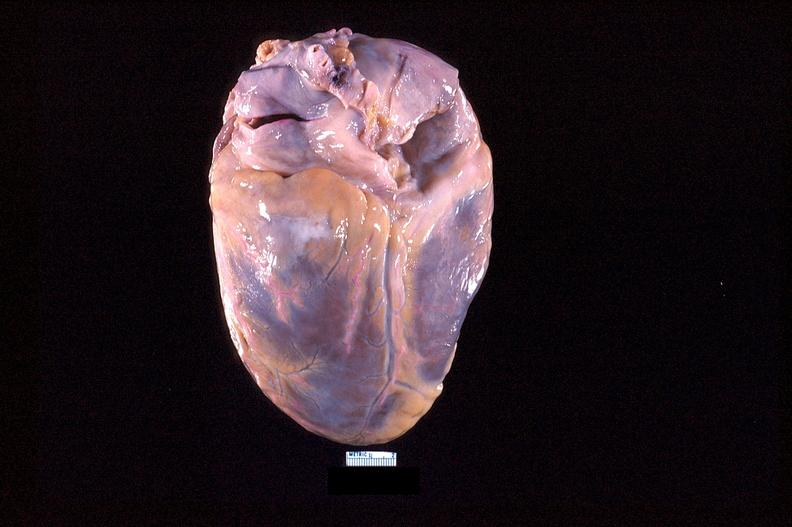what is present?
Answer the question using a single word or phrase. Cardiovascular 